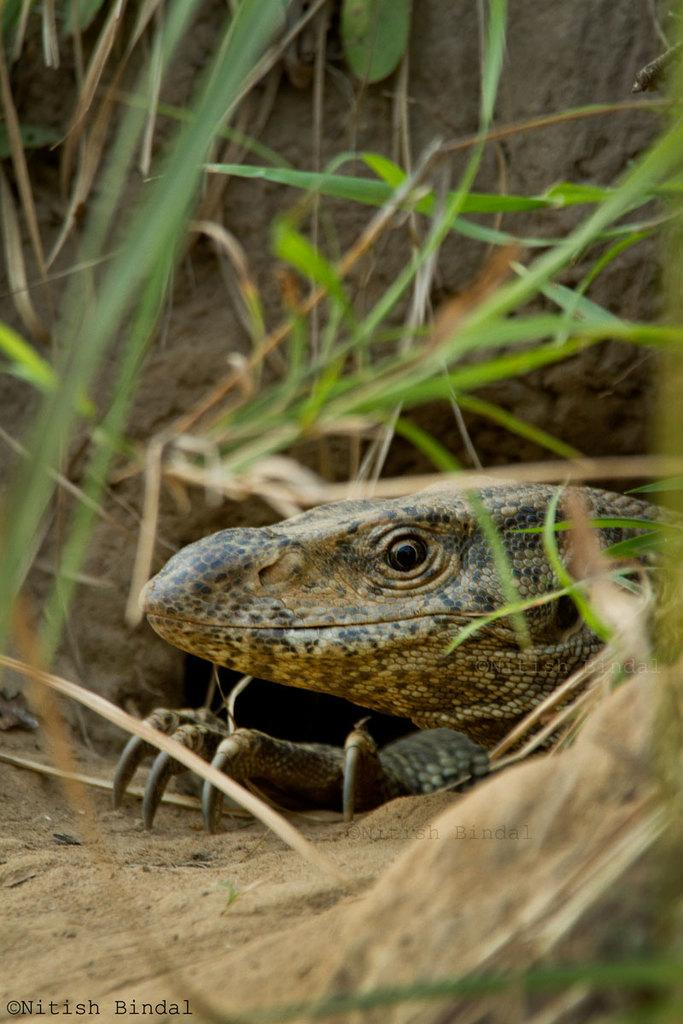What type of animal is in the image? There is a reptile in the image. Where is the reptile located? The reptile is on the ground. What type of environment is visible in the image? There is grass visible in the image. What is the reptile doing to the person's throat in the image? There is no person or throat present in the image; it only features a reptile on the ground. 